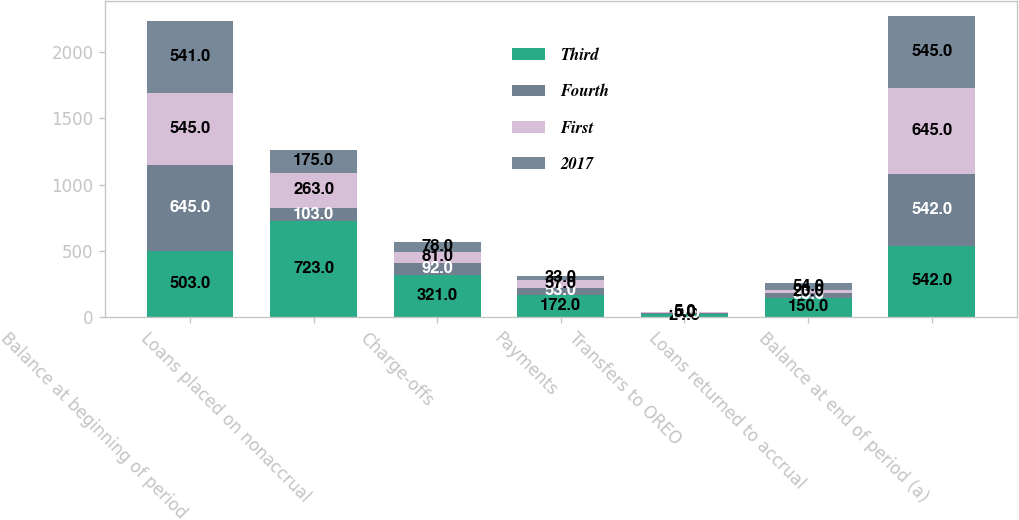<chart> <loc_0><loc_0><loc_500><loc_500><stacked_bar_chart><ecel><fcel>Balance at beginning of period<fcel>Loans placed on nonaccrual<fcel>Charge-offs<fcel>Payments<fcel>Transfers to OREO<fcel>Loans returned to accrual<fcel>Balance at end of period (a)<nl><fcel>Third<fcel>503<fcel>723<fcel>321<fcel>172<fcel>24<fcel>150<fcel>542<nl><fcel>Fourth<fcel>645<fcel>103<fcel>92<fcel>53<fcel>10<fcel>35<fcel>542<nl><fcel>First<fcel>545<fcel>263<fcel>81<fcel>57<fcel>5<fcel>20<fcel>645<nl><fcel>2017<fcel>541<fcel>175<fcel>78<fcel>33<fcel>5<fcel>54<fcel>545<nl></chart> 